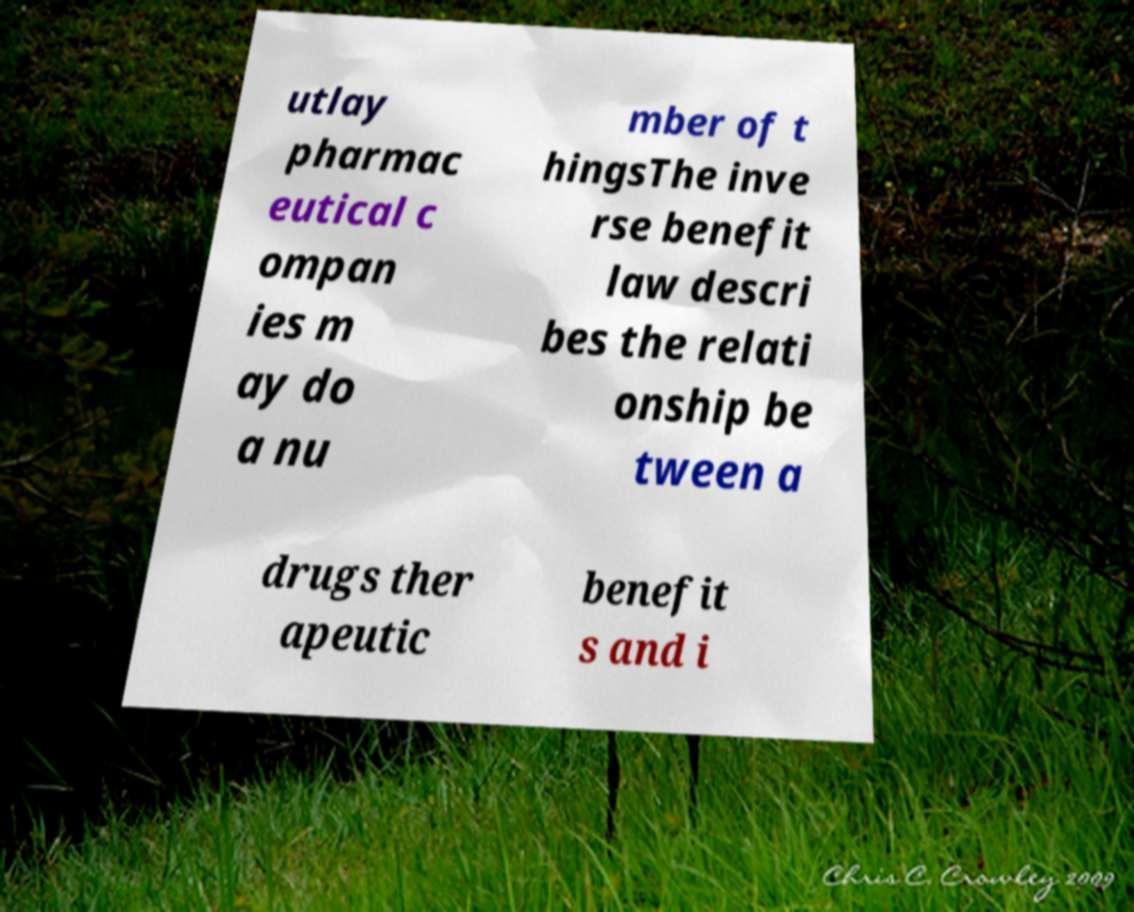Please identify and transcribe the text found in this image. utlay pharmac eutical c ompan ies m ay do a nu mber of t hingsThe inve rse benefit law descri bes the relati onship be tween a drugs ther apeutic benefit s and i 